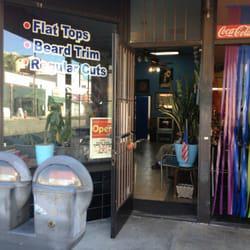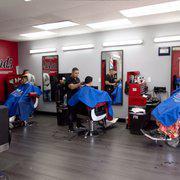The first image is the image on the left, the second image is the image on the right. Analyze the images presented: Is the assertion "The combined images include two barber shop doors and two barber poles." valid? Answer yes or no. No. The first image is the image on the left, the second image is the image on the right. Considering the images on both sides, is "In at least one image there are three people getting their haircut." valid? Answer yes or no. Yes. 